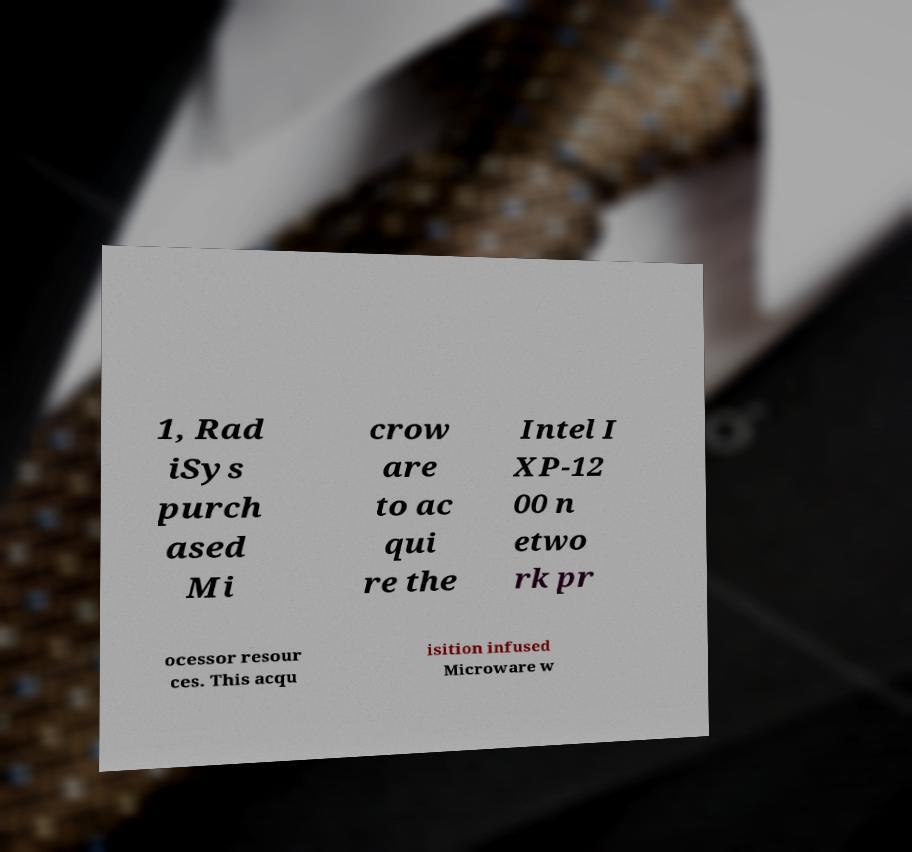Please identify and transcribe the text found in this image. 1, Rad iSys purch ased Mi crow are to ac qui re the Intel I XP-12 00 n etwo rk pr ocessor resour ces. This acqu isition infused Microware w 